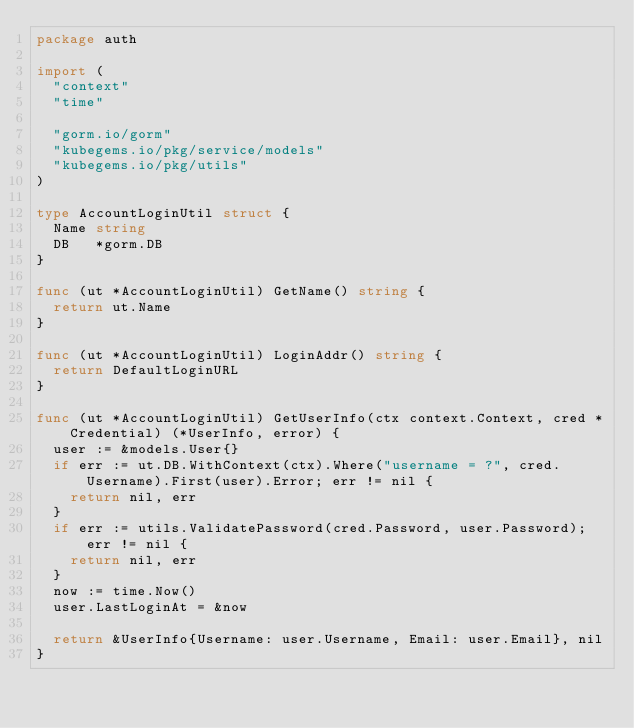Convert code to text. <code><loc_0><loc_0><loc_500><loc_500><_Go_>package auth

import (
	"context"
	"time"

	"gorm.io/gorm"
	"kubegems.io/pkg/service/models"
	"kubegems.io/pkg/utils"
)

type AccountLoginUtil struct {
	Name string
	DB   *gorm.DB
}

func (ut *AccountLoginUtil) GetName() string {
	return ut.Name
}

func (ut *AccountLoginUtil) LoginAddr() string {
	return DefaultLoginURL
}

func (ut *AccountLoginUtil) GetUserInfo(ctx context.Context, cred *Credential) (*UserInfo, error) {
	user := &models.User{}
	if err := ut.DB.WithContext(ctx).Where("username = ?", cred.Username).First(user).Error; err != nil {
		return nil, err
	}
	if err := utils.ValidatePassword(cred.Password, user.Password); err != nil {
		return nil, err
	}
	now := time.Now()
	user.LastLoginAt = &now

	return &UserInfo{Username: user.Username, Email: user.Email}, nil
}
</code> 